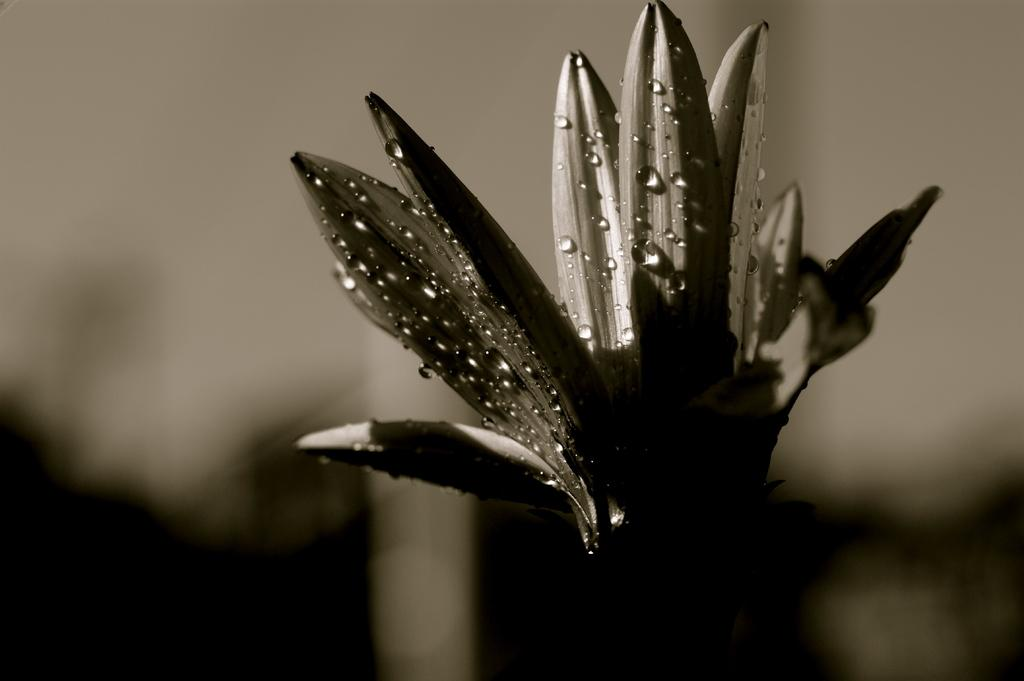What is the main subject of the image? The main subject of the image is a flower with water drops on it. Can you describe the condition of the flower in the image? The flower has water drops on it. What can be observed about the background of the image? The background of the image is blurry. What type of muscle is being flexed by the flower in the image? There is no muscle present in the image, as it features a flower with water drops and a blurry background. 